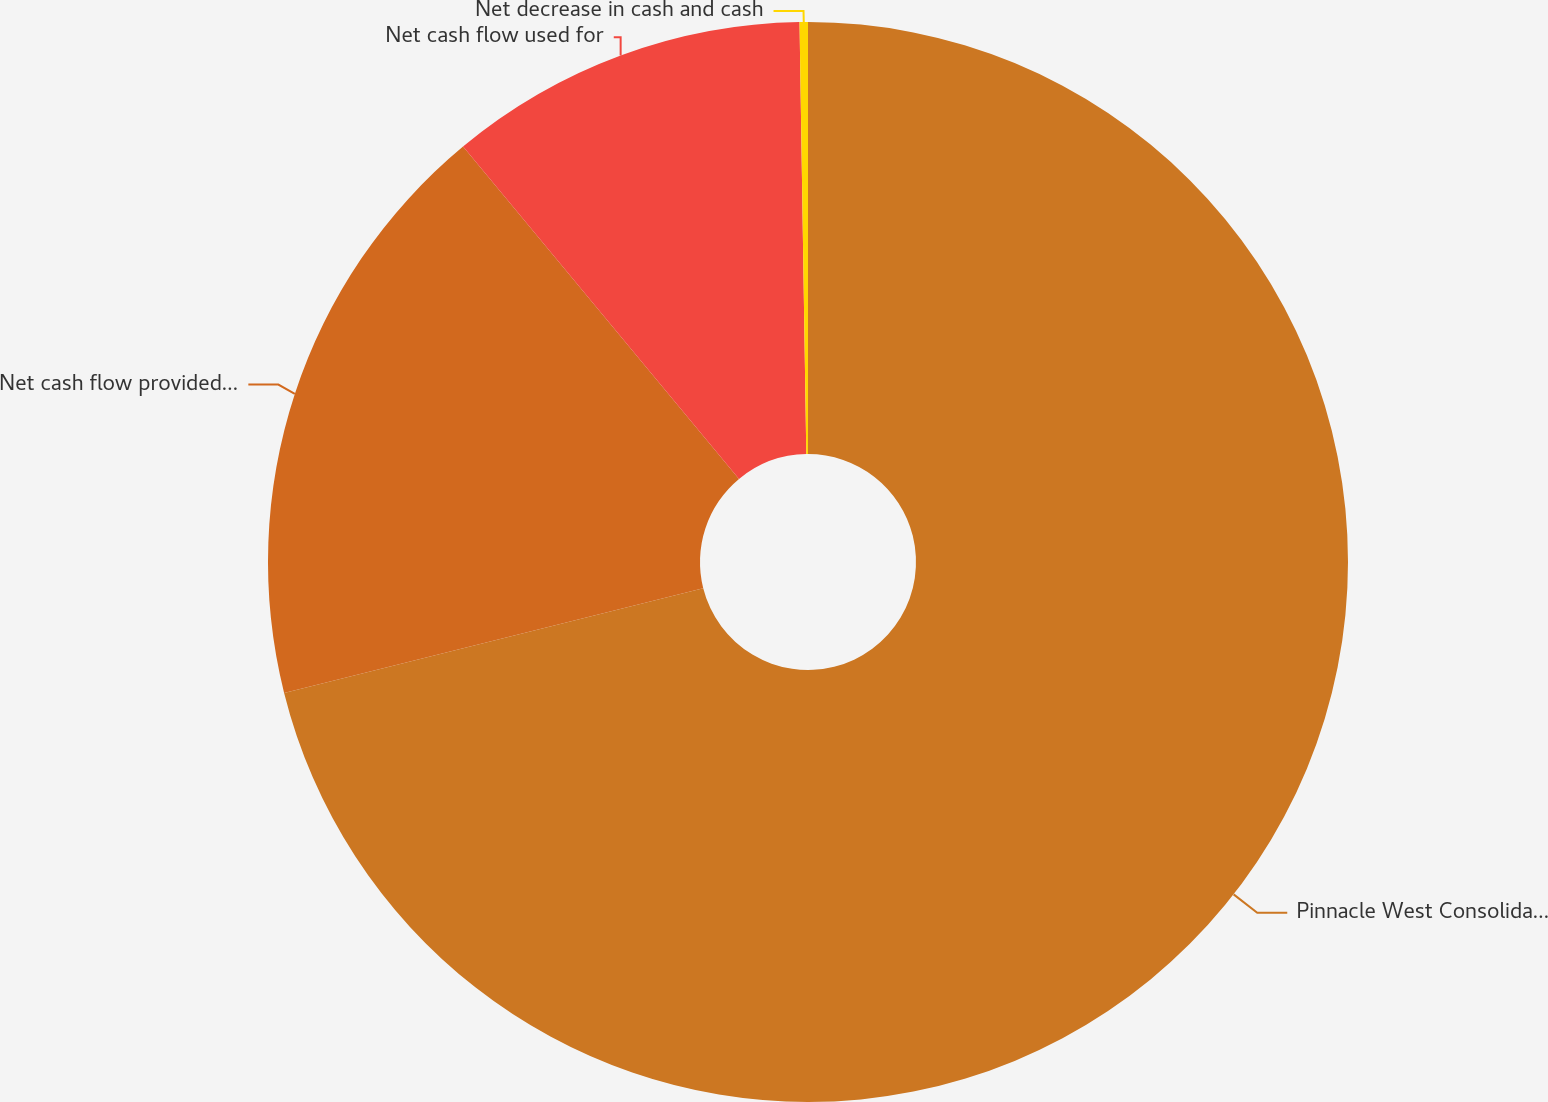Convert chart. <chart><loc_0><loc_0><loc_500><loc_500><pie_chart><fcel>Pinnacle West Consolidated<fcel>Net cash flow provided by<fcel>Net cash flow used for<fcel>Net decrease in cash and cash<nl><fcel>71.11%<fcel>17.87%<fcel>10.78%<fcel>0.25%<nl></chart> 